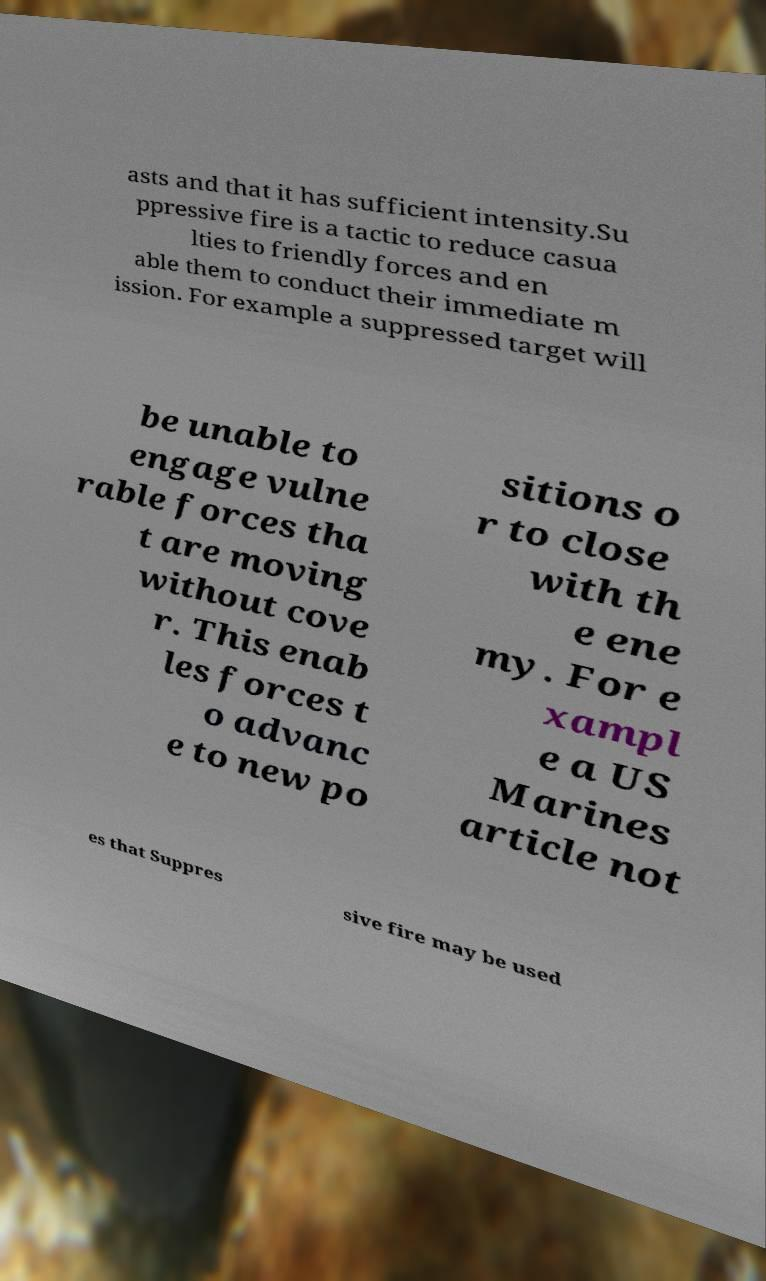What messages or text are displayed in this image? I need them in a readable, typed format. asts and that it has sufficient intensity.Su ppressive fire is a tactic to reduce casua lties to friendly forces and en able them to conduct their immediate m ission. For example a suppressed target will be unable to engage vulne rable forces tha t are moving without cove r. This enab les forces t o advanc e to new po sitions o r to close with th e ene my. For e xampl e a US Marines article not es that Suppres sive fire may be used 